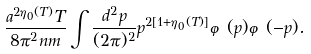Convert formula to latex. <formula><loc_0><loc_0><loc_500><loc_500>\frac { a ^ { 2 \eta _ { 0 } ( T ) } T } { 8 \pi ^ { 2 } n m } \int \frac { d ^ { 2 } p } { ( 2 \pi ) ^ { 2 } } p ^ { 2 [ 1 + \eta _ { 0 } ( T ) ] } \varphi ( { p } ) \varphi ( - { p } ) .</formula> 